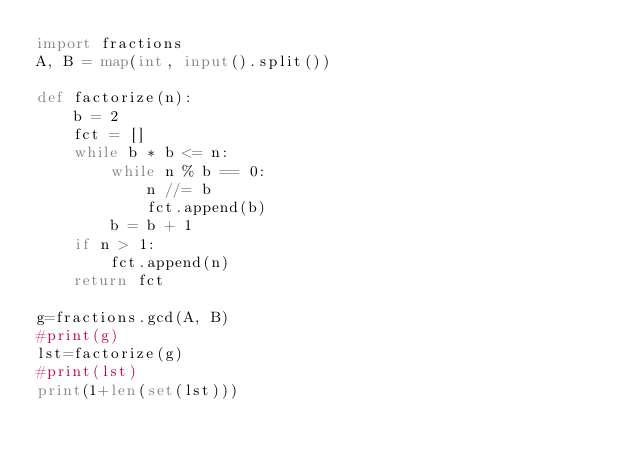<code> <loc_0><loc_0><loc_500><loc_500><_Python_>import fractions
A, B = map(int, input().split())

def factorize(n):
    b = 2
    fct = []
    while b * b <= n:
        while n % b == 0:
            n //= b
            fct.append(b)
        b = b + 1
    if n > 1:
        fct.append(n)
    return fct

g=fractions.gcd(A, B)
#print(g)
lst=factorize(g)
#print(lst)
print(1+len(set(lst)))</code> 